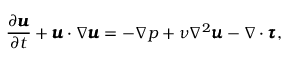<formula> <loc_0><loc_0><loc_500><loc_500>\frac { \partial \pm b { u } } { \partial t } + \pm b { u } \cdot \nabla \pm b { u } = - \nabla p + \nu \nabla ^ { 2 } \pm b { u } - \nabla \cdot \pm b { \tau } ,</formula> 